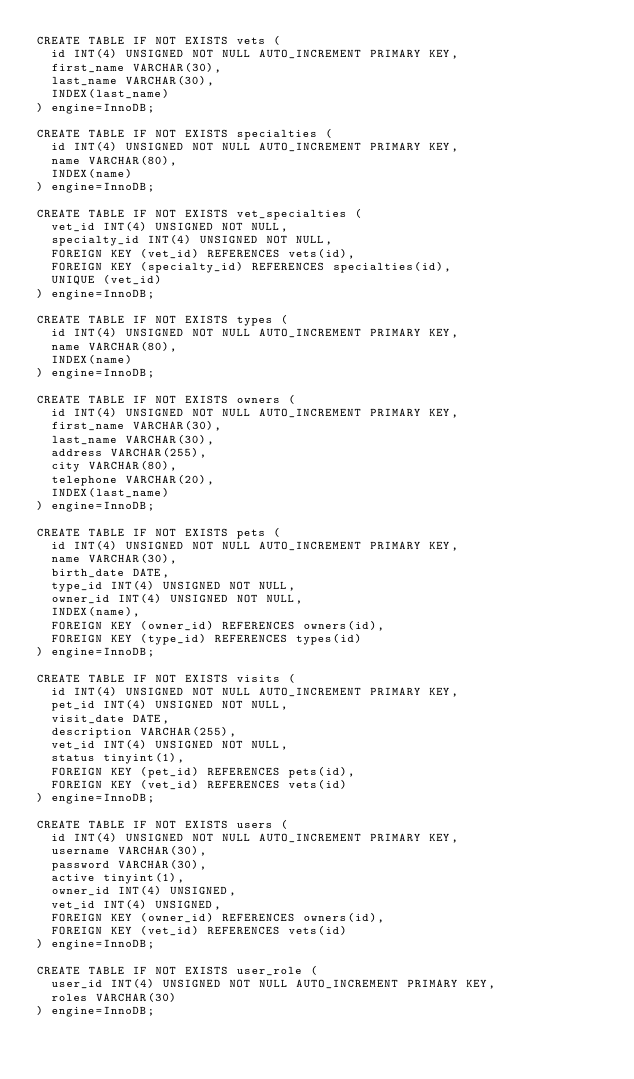Convert code to text. <code><loc_0><loc_0><loc_500><loc_500><_SQL_>CREATE TABLE IF NOT EXISTS vets (
  id INT(4) UNSIGNED NOT NULL AUTO_INCREMENT PRIMARY KEY,
  first_name VARCHAR(30),
  last_name VARCHAR(30),
  INDEX(last_name)
) engine=InnoDB;

CREATE TABLE IF NOT EXISTS specialties (
  id INT(4) UNSIGNED NOT NULL AUTO_INCREMENT PRIMARY KEY,
  name VARCHAR(80),
  INDEX(name)
) engine=InnoDB;

CREATE TABLE IF NOT EXISTS vet_specialties (
  vet_id INT(4) UNSIGNED NOT NULL,
  specialty_id INT(4) UNSIGNED NOT NULL,
  FOREIGN KEY (vet_id) REFERENCES vets(id),
  FOREIGN KEY (specialty_id) REFERENCES specialties(id),
  UNIQUE (vet_id)
) engine=InnoDB;

CREATE TABLE IF NOT EXISTS types (
  id INT(4) UNSIGNED NOT NULL AUTO_INCREMENT PRIMARY KEY,
  name VARCHAR(80),
  INDEX(name)
) engine=InnoDB;

CREATE TABLE IF NOT EXISTS owners (
  id INT(4) UNSIGNED NOT NULL AUTO_INCREMENT PRIMARY KEY,
  first_name VARCHAR(30),
  last_name VARCHAR(30),
  address VARCHAR(255),
  city VARCHAR(80),
  telephone VARCHAR(20),
  INDEX(last_name)
) engine=InnoDB;

CREATE TABLE IF NOT EXISTS pets (
  id INT(4) UNSIGNED NOT NULL AUTO_INCREMENT PRIMARY KEY,
  name VARCHAR(30),
  birth_date DATE,
  type_id INT(4) UNSIGNED NOT NULL,
  owner_id INT(4) UNSIGNED NOT NULL,
  INDEX(name),
  FOREIGN KEY (owner_id) REFERENCES owners(id),
  FOREIGN KEY (type_id) REFERENCES types(id)
) engine=InnoDB;

CREATE TABLE IF NOT EXISTS visits (
  id INT(4) UNSIGNED NOT NULL AUTO_INCREMENT PRIMARY KEY,
  pet_id INT(4) UNSIGNED NOT NULL,
  visit_date DATE,
  description VARCHAR(255),
  vet_id INT(4) UNSIGNED NOT NULL,
  status tinyint(1),
  FOREIGN KEY (pet_id) REFERENCES pets(id),
  FOREIGN KEY (vet_id) REFERENCES vets(id)
) engine=InnoDB;

CREATE TABLE IF NOT EXISTS users (
  id INT(4) UNSIGNED NOT NULL AUTO_INCREMENT PRIMARY KEY,
  username VARCHAR(30),
  password VARCHAR(30),
  active tinyint(1),
  owner_id INT(4) UNSIGNED,
  vet_id INT(4) UNSIGNED,
  FOREIGN KEY (owner_id) REFERENCES owners(id),
  FOREIGN KEY (vet_id) REFERENCES vets(id)
) engine=InnoDB;

CREATE TABLE IF NOT EXISTS user_role (
  user_id INT(4) UNSIGNED NOT NULL AUTO_INCREMENT PRIMARY KEY,
  roles VARCHAR(30)
) engine=InnoDB;
</code> 